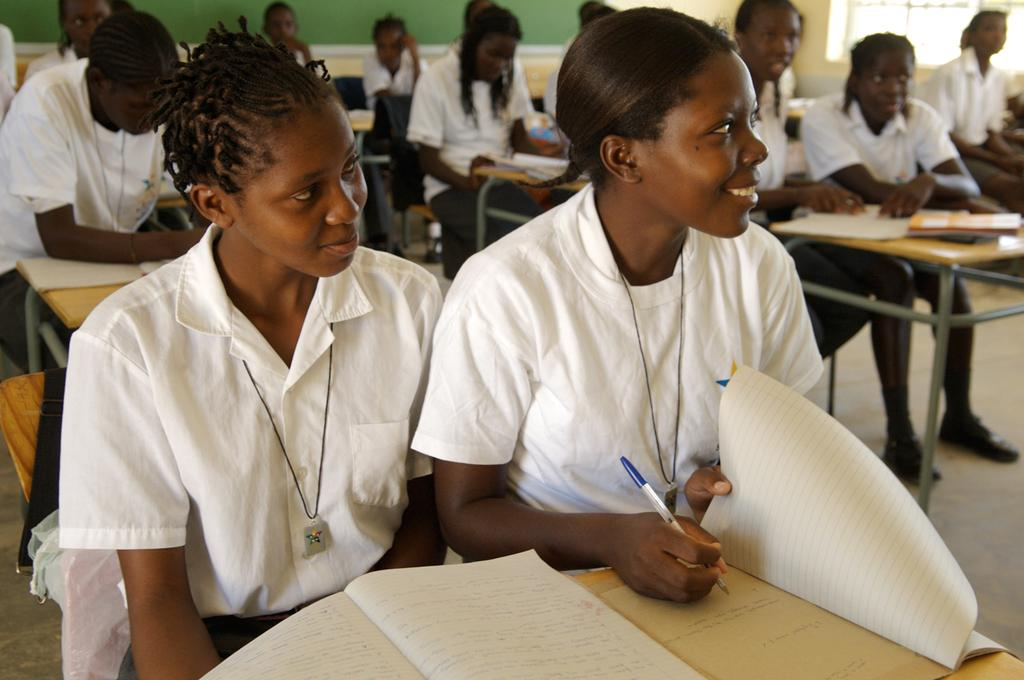What type of setting is shown in the image? The image depicts a classroom. What are the people in the image doing? People are seated on benches in the classroom. What items can be seen on the benches? Books are present on the benches. How many kittens are playing with a card on the teacher's desk in the image? There are no kittens or cards present on the teacher's desk in the image. 